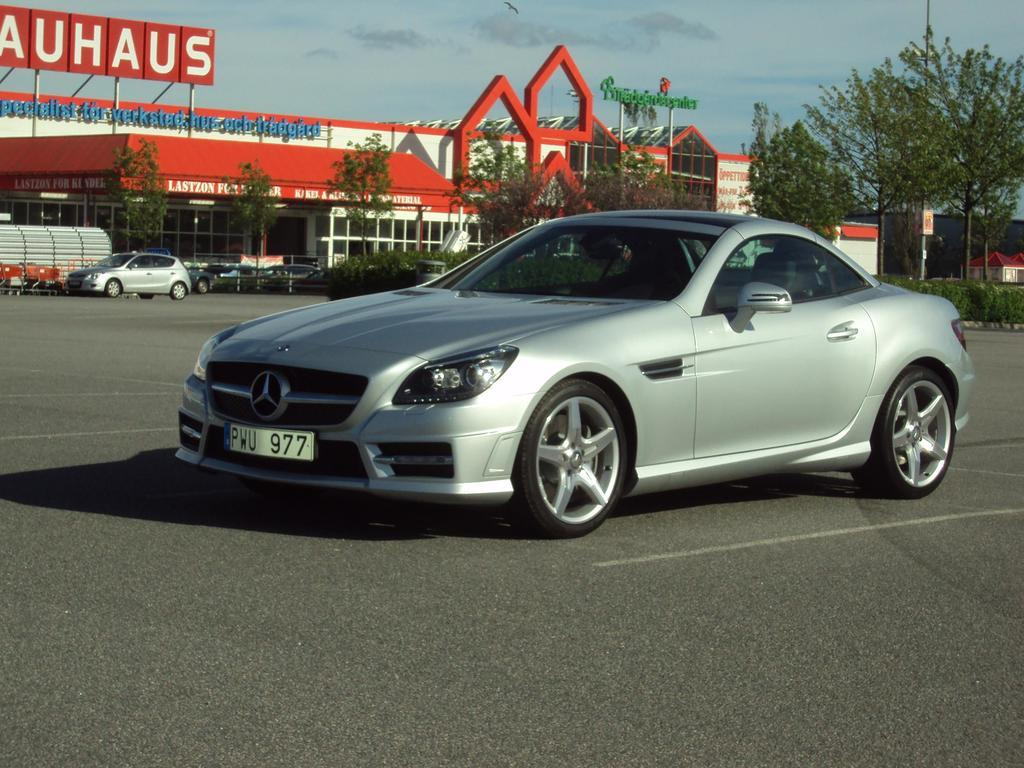<image>
Summarize the visual content of the image. The license plate of the car includes a series of three letters and three numbers. 